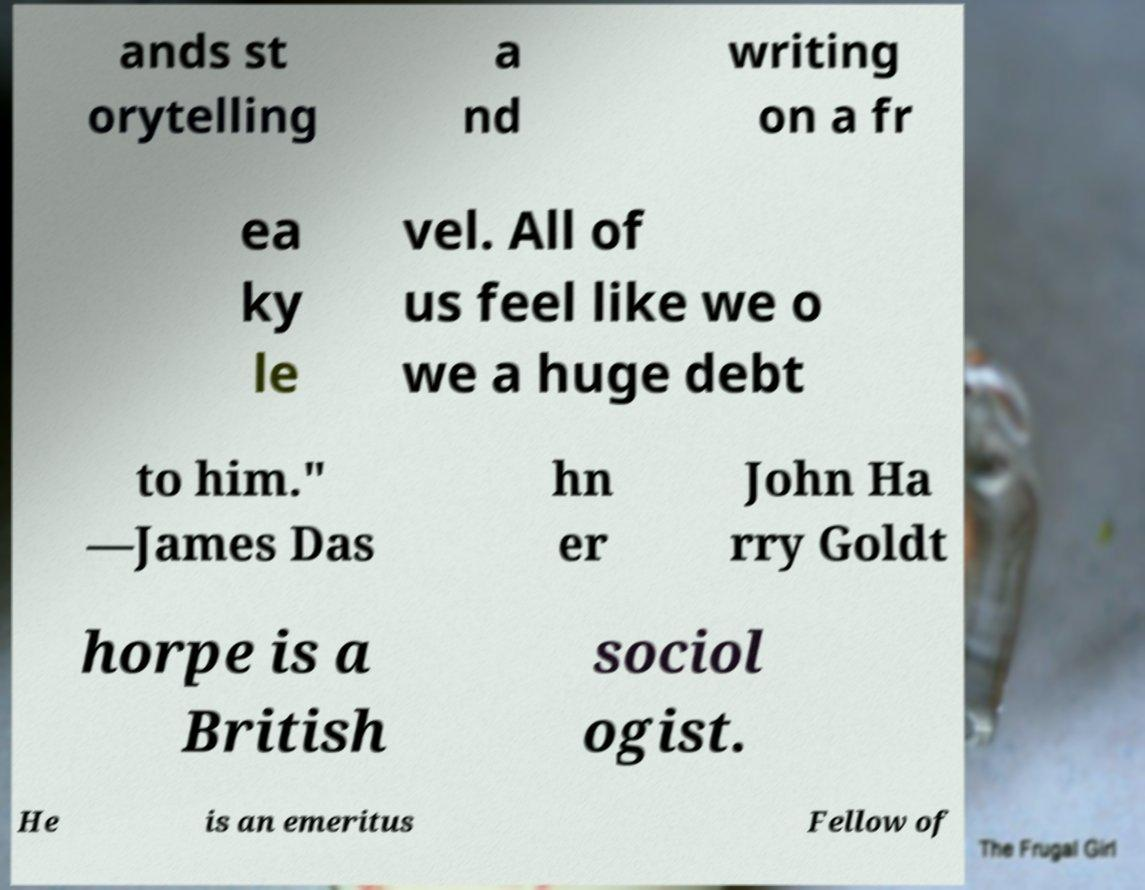Can you accurately transcribe the text from the provided image for me? ands st orytelling a nd writing on a fr ea ky le vel. All of us feel like we o we a huge debt to him." —James Das hn er John Ha rry Goldt horpe is a British sociol ogist. He is an emeritus Fellow of 